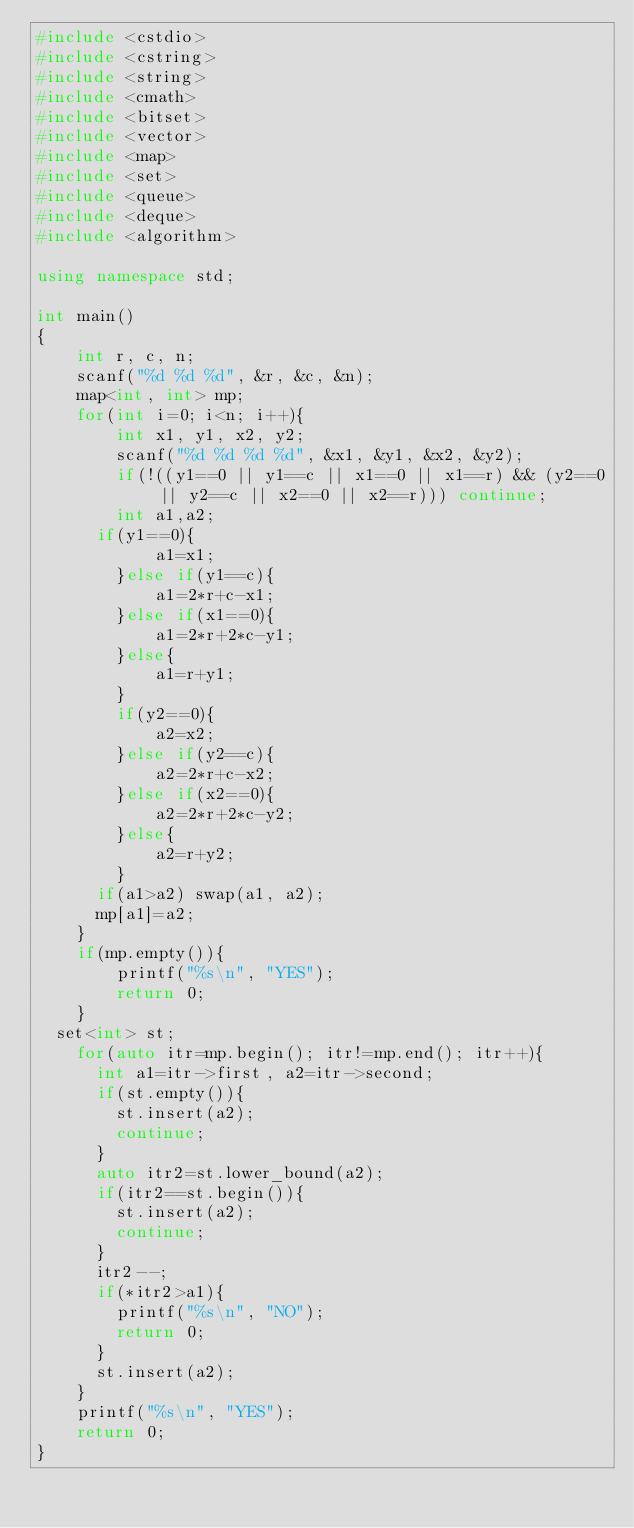Convert code to text. <code><loc_0><loc_0><loc_500><loc_500><_C++_>#include <cstdio>
#include <cstring>
#include <string>
#include <cmath>
#include <bitset>
#include <vector>
#include <map>
#include <set>
#include <queue>
#include <deque>
#include <algorithm>

using namespace std;

int main()
{
	int r, c, n;
	scanf("%d %d %d", &r, &c, &n);
	map<int, int> mp;
	for(int i=0; i<n; i++){
		int x1, y1, x2, y2;
		scanf("%d %d %d %d", &x1, &y1, &x2, &y2);
		if(!((y1==0 || y1==c || x1==0 || x1==r) && (y2==0 || y2==c || x2==0 || x2==r))) continue;
		int a1,a2;
      if(y1==0){
			a1=x1;
		}else if(y1==c){
			a1=2*r+c-x1;
		}else if(x1==0){
			a1=2*r+2*c-y1;
		}else{
			a1=r+y1;
		}
		if(y2==0){
			a2=x2;
		}else if(y2==c){
			a2=2*r+c-x2;
		}else if(x2==0){
			a2=2*r+2*c-y2;
		}else{
			a2=r+y2;
		}
      if(a1>a2) swap(a1, a2);
      mp[a1]=a2;
	}
	if(mp.empty()){
		printf("%s\n", "YES");
		return 0;
	}
  set<int> st;
	for(auto itr=mp.begin(); itr!=mp.end(); itr++){
      int a1=itr->first, a2=itr->second;
      if(st.empty()){
        st.insert(a2);
        continue;
      }
      auto itr2=st.lower_bound(a2);
      if(itr2==st.begin()){
        st.insert(a2);
        continue;
      }
      itr2--;
      if(*itr2>a1){
        printf("%s\n", "NO");
        return 0;
      }
      st.insert(a2);
    }
	printf("%s\n", "YES");
	return 0;
}
</code> 